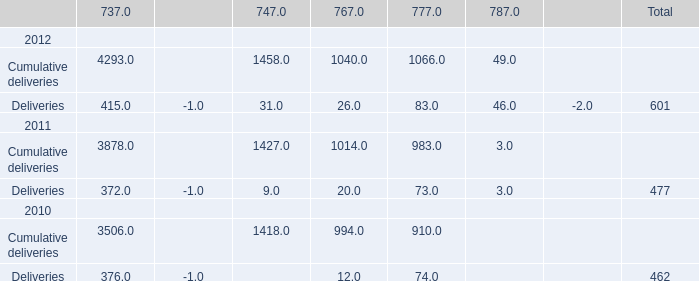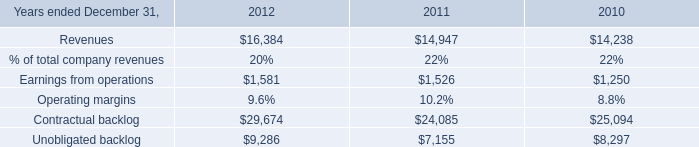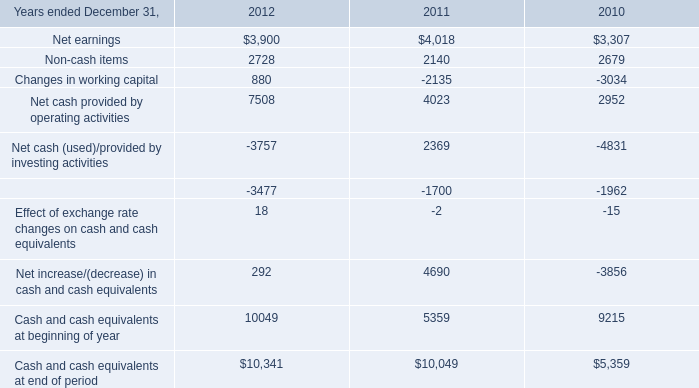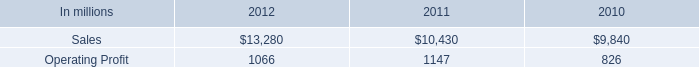north american industrial packaging net sales where what percent of industrial packaging sales in 2012? 
Computations: ((11.6 * 1000) / 13280)
Answer: 0.87349. 